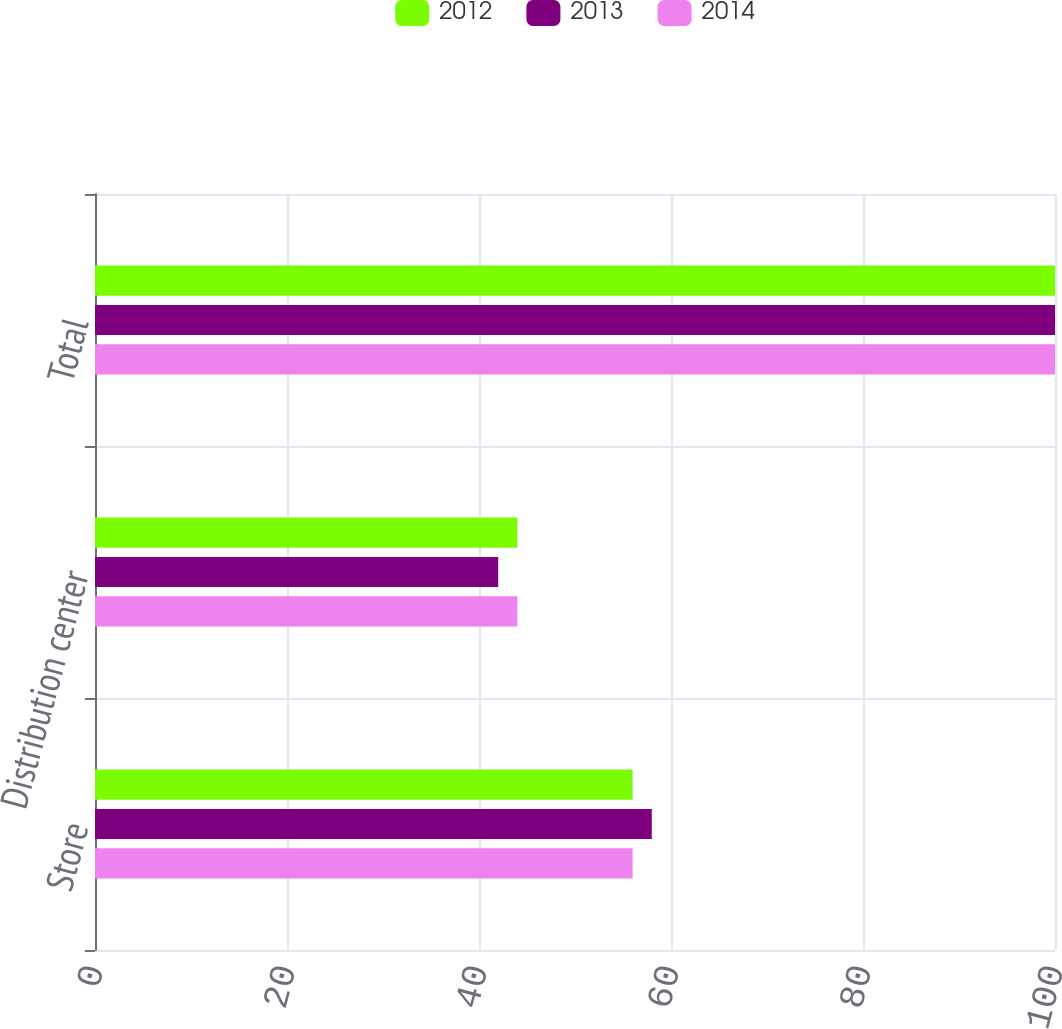Convert chart to OTSL. <chart><loc_0><loc_0><loc_500><loc_500><stacked_bar_chart><ecel><fcel>Store<fcel>Distribution center<fcel>Total<nl><fcel>2012<fcel>56<fcel>44<fcel>100<nl><fcel>2013<fcel>58<fcel>42<fcel>100<nl><fcel>2014<fcel>56<fcel>44<fcel>100<nl></chart> 